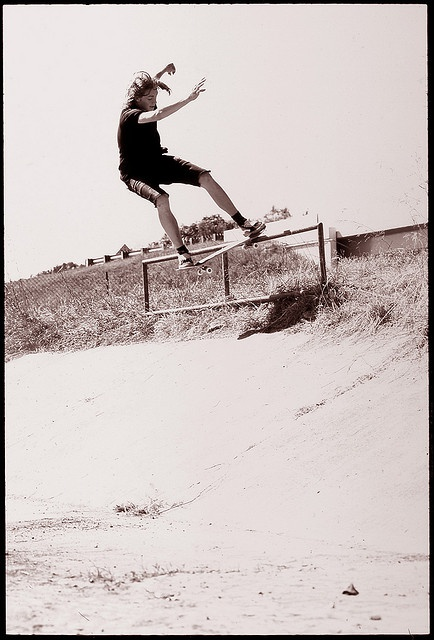Describe the objects in this image and their specific colors. I can see people in black, brown, gray, and lightgray tones and skateboard in black, lightgray, gray, and darkgray tones in this image. 